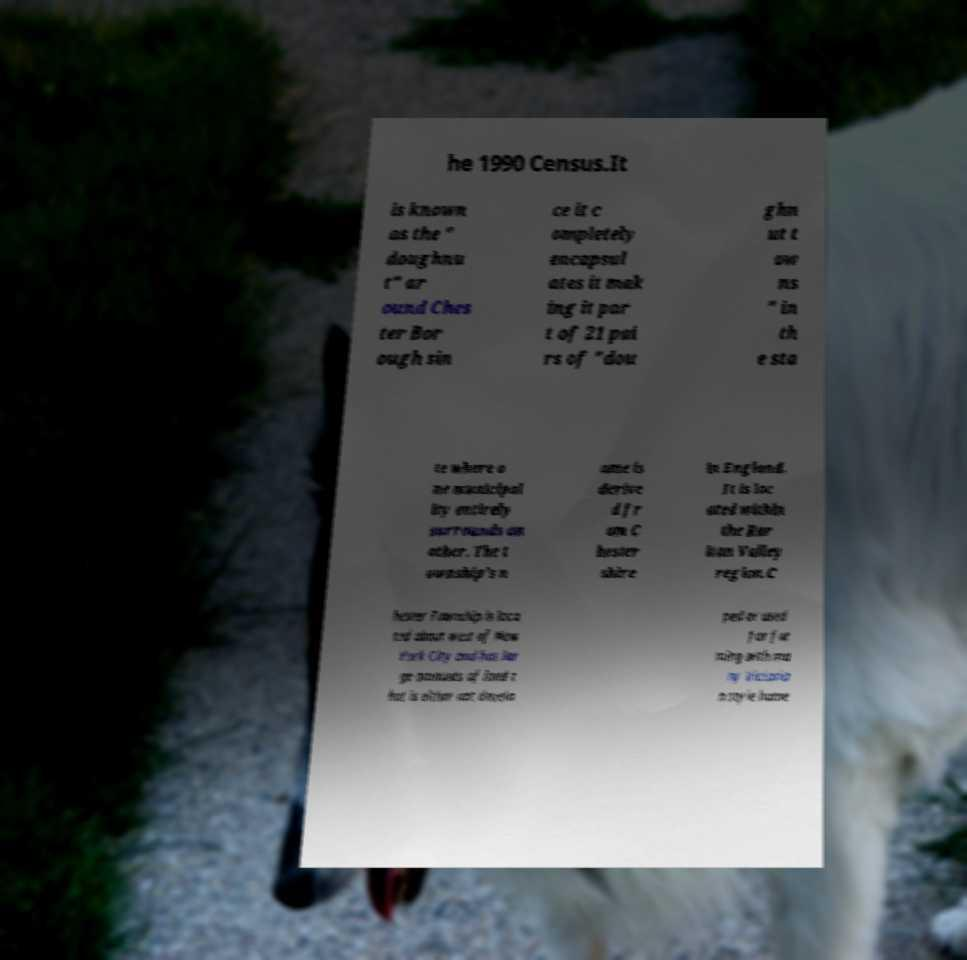Could you extract and type out the text from this image? he 1990 Census.It is known as the " doughnu t" ar ound Ches ter Bor ough sin ce it c ompletely encapsul ates it mak ing it par t of 21 pai rs of "dou ghn ut t ow ns " in th e sta te where o ne municipal ity entirely surrounds an other. The t ownship's n ame is derive d fr om C hester shire in England. It is loc ated within the Rar itan Valley region.C hester Township is loca ted about west of New York City and has lar ge amounts of land t hat is either not develo ped or used for far ming with ma ny Victoria n style home 